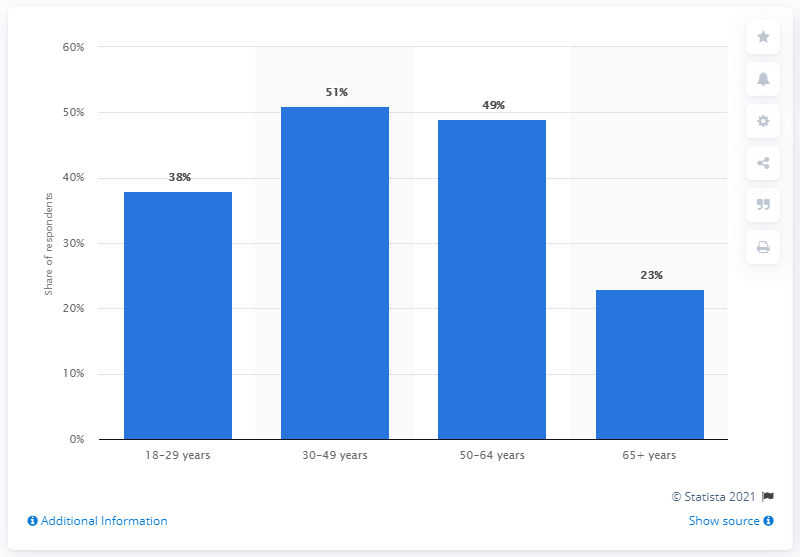Mention a couple of crucial points in this snapshot. The average of 30-49, 50-64 years old is 50 years old. The share of 18-29 year old patients in the hospital is 38%. 